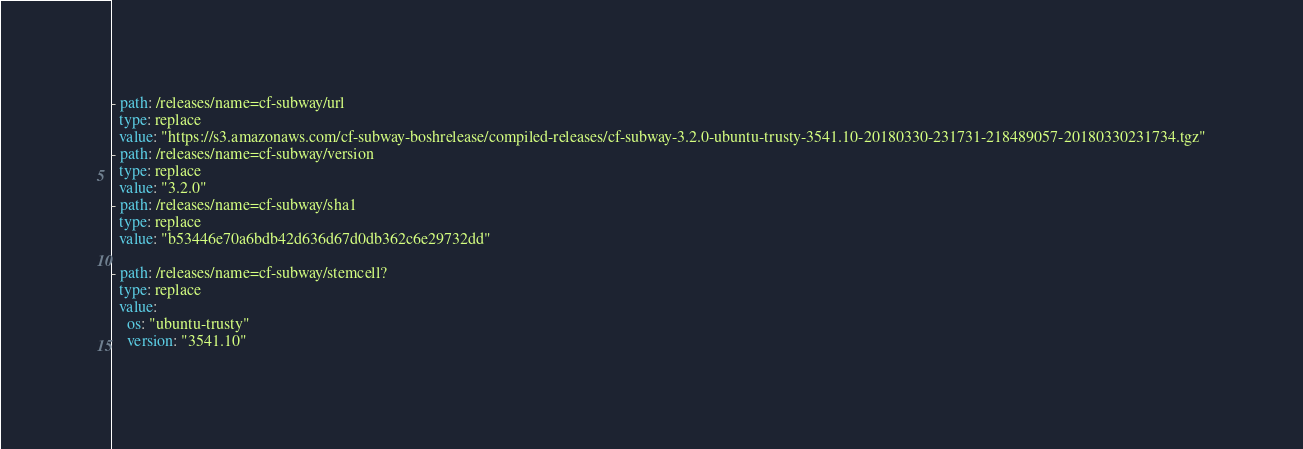<code> <loc_0><loc_0><loc_500><loc_500><_YAML_>- path: /releases/name=cf-subway/url
  type: replace
  value: "https://s3.amazonaws.com/cf-subway-boshrelease/compiled-releases/cf-subway-3.2.0-ubuntu-trusty-3541.10-20180330-231731-218489057-20180330231734.tgz"
- path: /releases/name=cf-subway/version
  type: replace
  value: "3.2.0"
- path: /releases/name=cf-subway/sha1
  type: replace
  value: "b53446e70a6bdb42d636d67d0db362c6e29732dd"

- path: /releases/name=cf-subway/stemcell?
  type: replace
  value:
    os: "ubuntu-trusty"
    version: "3541.10"
</code> 